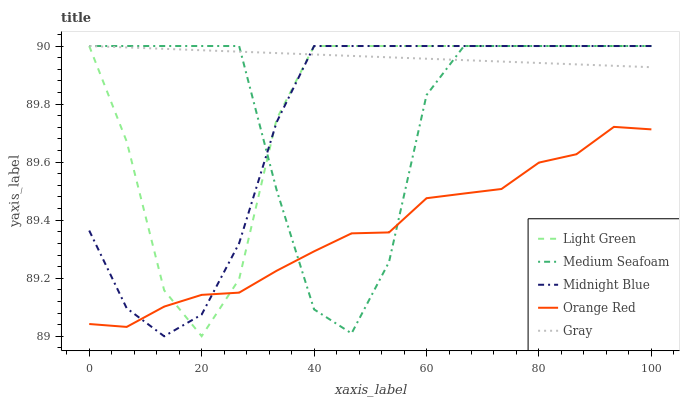Does Orange Red have the minimum area under the curve?
Answer yes or no. Yes. Does Gray have the maximum area under the curve?
Answer yes or no. Yes. Does Medium Seafoam have the minimum area under the curve?
Answer yes or no. No. Does Medium Seafoam have the maximum area under the curve?
Answer yes or no. No. Is Gray the smoothest?
Answer yes or no. Yes. Is Medium Seafoam the roughest?
Answer yes or no. Yes. Is Orange Red the smoothest?
Answer yes or no. No. Is Orange Red the roughest?
Answer yes or no. No. Does Orange Red have the lowest value?
Answer yes or no. No. Does Midnight Blue have the highest value?
Answer yes or no. Yes. Does Orange Red have the highest value?
Answer yes or no. No. Is Orange Red less than Gray?
Answer yes or no. Yes. Is Gray greater than Orange Red?
Answer yes or no. Yes. Does Medium Seafoam intersect Orange Red?
Answer yes or no. Yes. Is Medium Seafoam less than Orange Red?
Answer yes or no. No. Is Medium Seafoam greater than Orange Red?
Answer yes or no. No. Does Orange Red intersect Gray?
Answer yes or no. No. 